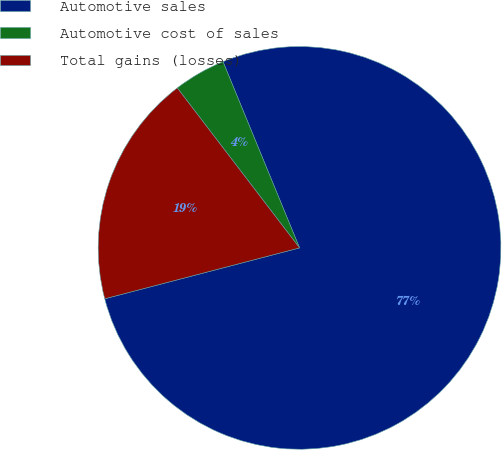<chart> <loc_0><loc_0><loc_500><loc_500><pie_chart><fcel>Automotive sales<fcel>Automotive cost of sales<fcel>Total gains (losses)<nl><fcel>77.14%<fcel>4.18%<fcel>18.68%<nl></chart> 